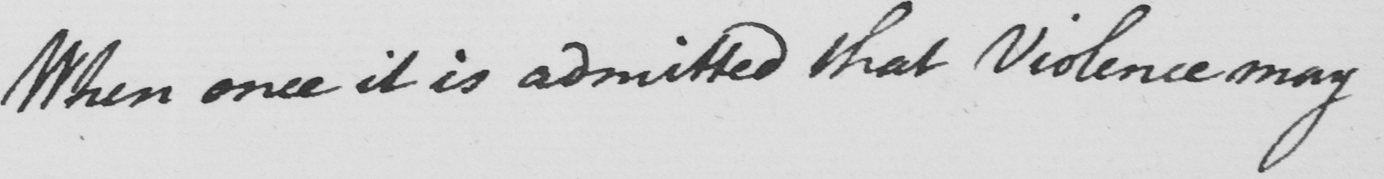Transcribe the text shown in this historical manuscript line. When once it is admitted that Violence may 